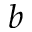<formula> <loc_0><loc_0><loc_500><loc_500>b</formula> 